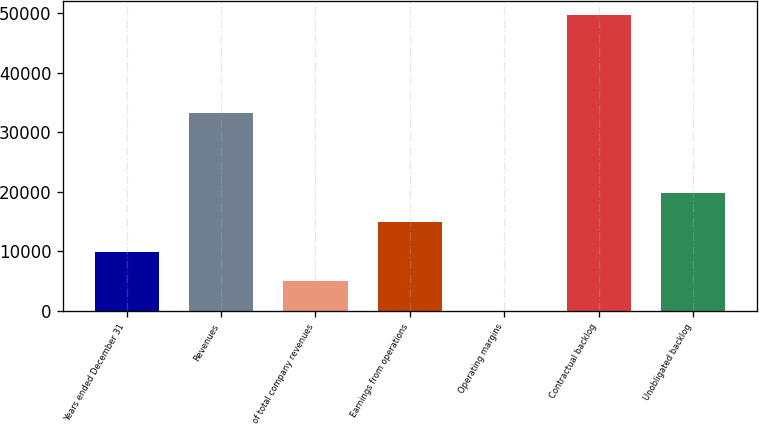<chart> <loc_0><loc_0><loc_500><loc_500><bar_chart><fcel>Years ended December 31<fcel>Revenues<fcel>of total company revenues<fcel>Earnings from operations<fcel>Operating margins<fcel>Contractual backlog<fcel>Unobligated backlog<nl><fcel>9943.96<fcel>33197<fcel>4976.83<fcel>14911.1<fcel>9.7<fcel>49681<fcel>19878.2<nl></chart> 